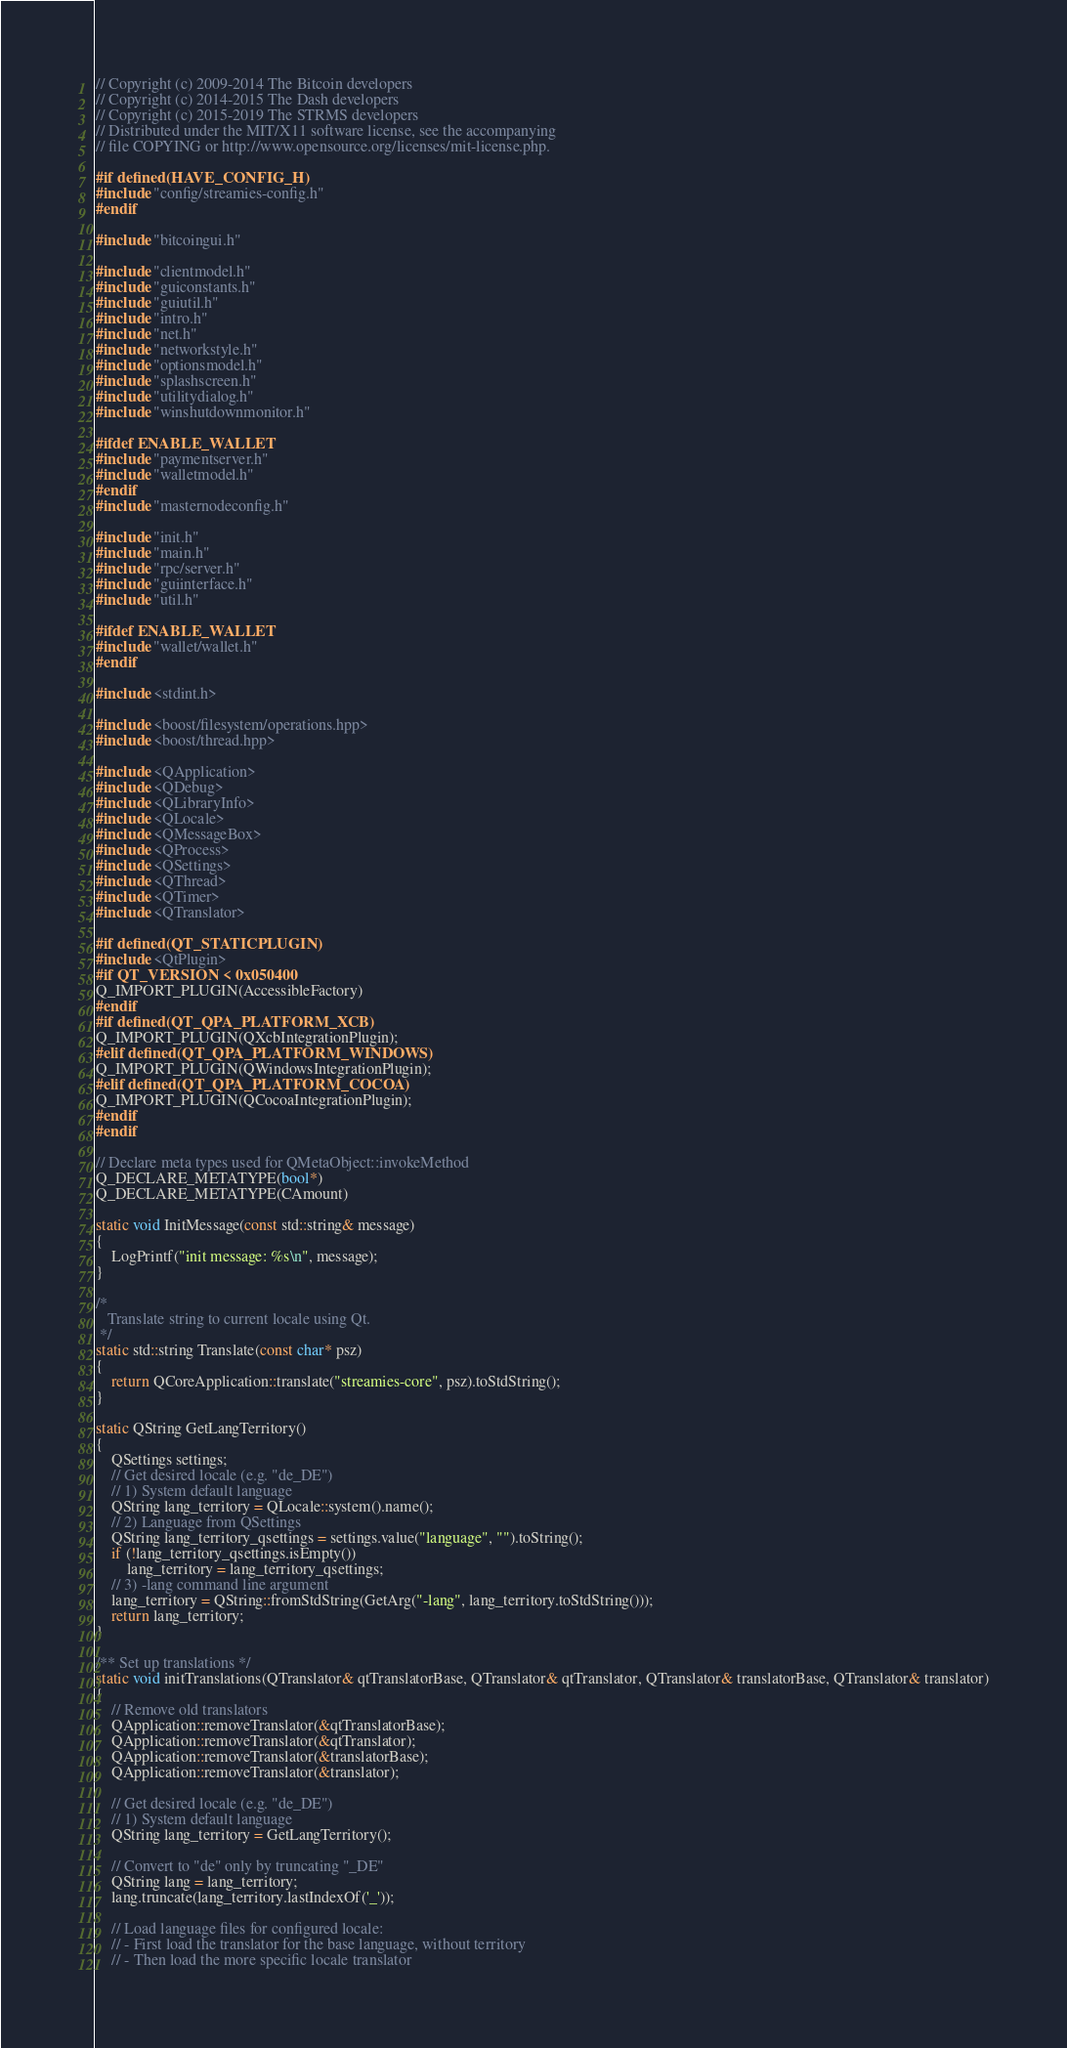Convert code to text. <code><loc_0><loc_0><loc_500><loc_500><_C++_>// Copyright (c) 2009-2014 The Bitcoin developers
// Copyright (c) 2014-2015 The Dash developers
// Copyright (c) 2015-2019 The STRMS developers
// Distributed under the MIT/X11 software license, see the accompanying
// file COPYING or http://www.opensource.org/licenses/mit-license.php.

#if defined(HAVE_CONFIG_H)
#include "config/streamies-config.h"
#endif

#include "bitcoingui.h"

#include "clientmodel.h"
#include "guiconstants.h"
#include "guiutil.h"
#include "intro.h"
#include "net.h"
#include "networkstyle.h"
#include "optionsmodel.h"
#include "splashscreen.h"
#include "utilitydialog.h"
#include "winshutdownmonitor.h"

#ifdef ENABLE_WALLET
#include "paymentserver.h"
#include "walletmodel.h"
#endif
#include "masternodeconfig.h"

#include "init.h"
#include "main.h"
#include "rpc/server.h"
#include "guiinterface.h"
#include "util.h"

#ifdef ENABLE_WALLET
#include "wallet/wallet.h"
#endif

#include <stdint.h>

#include <boost/filesystem/operations.hpp>
#include <boost/thread.hpp>

#include <QApplication>
#include <QDebug>
#include <QLibraryInfo>
#include <QLocale>
#include <QMessageBox>
#include <QProcess>
#include <QSettings>
#include <QThread>
#include <QTimer>
#include <QTranslator>

#if defined(QT_STATICPLUGIN)
#include <QtPlugin>
#if QT_VERSION < 0x050400
Q_IMPORT_PLUGIN(AccessibleFactory)
#endif
#if defined(QT_QPA_PLATFORM_XCB)
Q_IMPORT_PLUGIN(QXcbIntegrationPlugin);
#elif defined(QT_QPA_PLATFORM_WINDOWS)
Q_IMPORT_PLUGIN(QWindowsIntegrationPlugin);
#elif defined(QT_QPA_PLATFORM_COCOA)
Q_IMPORT_PLUGIN(QCocoaIntegrationPlugin);
#endif
#endif

// Declare meta types used for QMetaObject::invokeMethod
Q_DECLARE_METATYPE(bool*)
Q_DECLARE_METATYPE(CAmount)

static void InitMessage(const std::string& message)
{
    LogPrintf("init message: %s\n", message);
}

/*
   Translate string to current locale using Qt.
 */
static std::string Translate(const char* psz)
{
    return QCoreApplication::translate("streamies-core", psz).toStdString();
}

static QString GetLangTerritory()
{
    QSettings settings;
    // Get desired locale (e.g. "de_DE")
    // 1) System default language
    QString lang_territory = QLocale::system().name();
    // 2) Language from QSettings
    QString lang_territory_qsettings = settings.value("language", "").toString();
    if (!lang_territory_qsettings.isEmpty())
        lang_territory = lang_territory_qsettings;
    // 3) -lang command line argument
    lang_territory = QString::fromStdString(GetArg("-lang", lang_territory.toStdString()));
    return lang_territory;
}

/** Set up translations */
static void initTranslations(QTranslator& qtTranslatorBase, QTranslator& qtTranslator, QTranslator& translatorBase, QTranslator& translator)
{
    // Remove old translators
    QApplication::removeTranslator(&qtTranslatorBase);
    QApplication::removeTranslator(&qtTranslator);
    QApplication::removeTranslator(&translatorBase);
    QApplication::removeTranslator(&translator);

    // Get desired locale (e.g. "de_DE")
    // 1) System default language
    QString lang_territory = GetLangTerritory();

    // Convert to "de" only by truncating "_DE"
    QString lang = lang_territory;
    lang.truncate(lang_territory.lastIndexOf('_'));

    // Load language files for configured locale:
    // - First load the translator for the base language, without territory
    // - Then load the more specific locale translator
</code> 